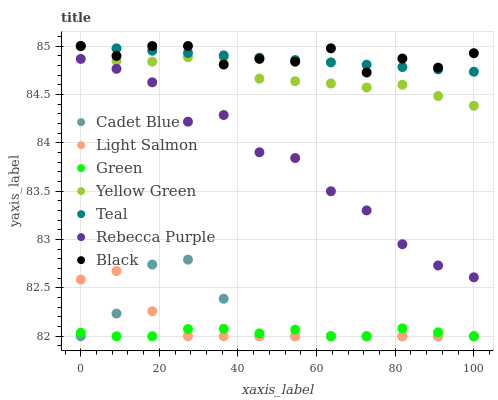Does Green have the minimum area under the curve?
Answer yes or no. Yes. Does Black have the maximum area under the curve?
Answer yes or no. Yes. Does Cadet Blue have the minimum area under the curve?
Answer yes or no. No. Does Cadet Blue have the maximum area under the curve?
Answer yes or no. No. Is Teal the smoothest?
Answer yes or no. Yes. Is Rebecca Purple the roughest?
Answer yes or no. Yes. Is Cadet Blue the smoothest?
Answer yes or no. No. Is Cadet Blue the roughest?
Answer yes or no. No. Does Light Salmon have the lowest value?
Answer yes or no. Yes. Does Yellow Green have the lowest value?
Answer yes or no. No. Does Black have the highest value?
Answer yes or no. Yes. Does Cadet Blue have the highest value?
Answer yes or no. No. Is Green less than Black?
Answer yes or no. Yes. Is Teal greater than Light Salmon?
Answer yes or no. Yes. Does Teal intersect Black?
Answer yes or no. Yes. Is Teal less than Black?
Answer yes or no. No. Is Teal greater than Black?
Answer yes or no. No. Does Green intersect Black?
Answer yes or no. No. 